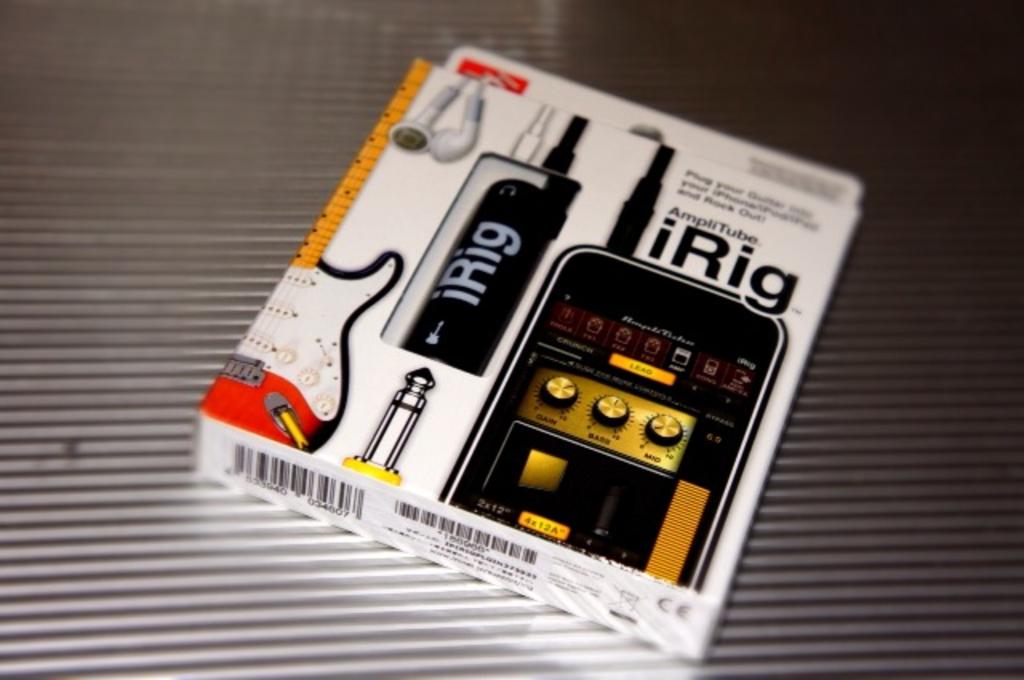What is the name of the item in the box?
Your answer should be very brief. Irig. 